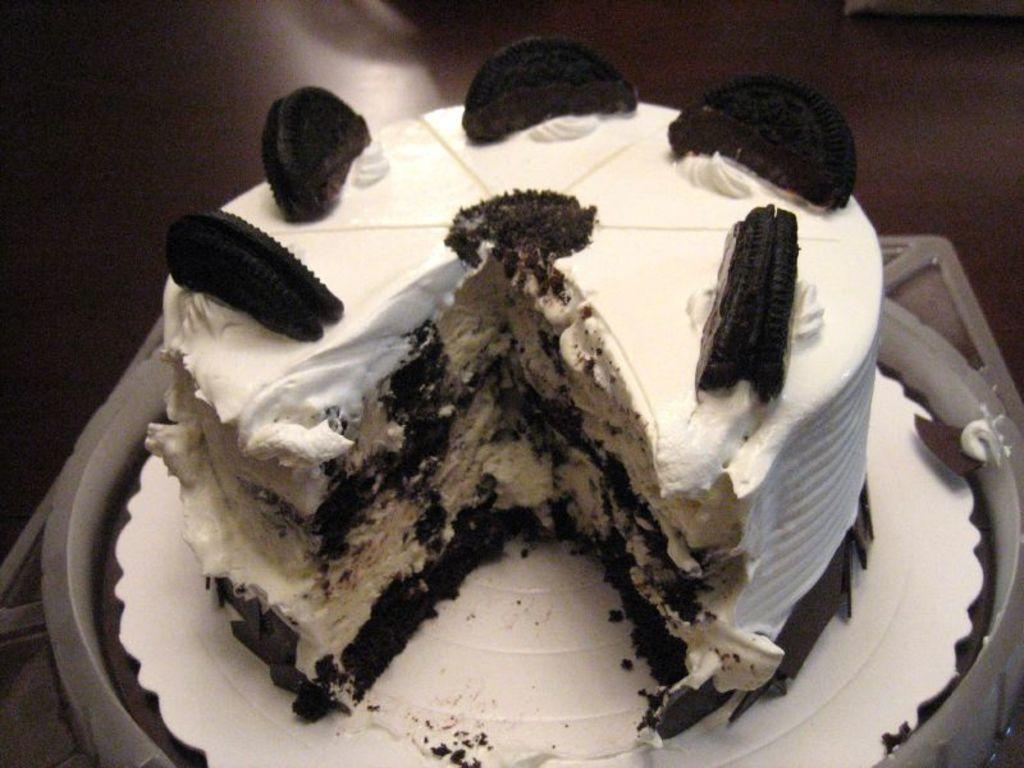What is the main subject of the image? There is a cake in the image. Can you describe the cake in the image? The image only shows a cake, but no specific details about its appearance or decoration are provided. What might be associated with the cake in the image? The cake could be part of a celebration or event, but there is no information to confirm this. What type of weather can be seen in the image? There is no information about the weather in the image, as it only features a cake. How does the cake feel about being in the image? The cake is an inanimate object and does not have feelings. 